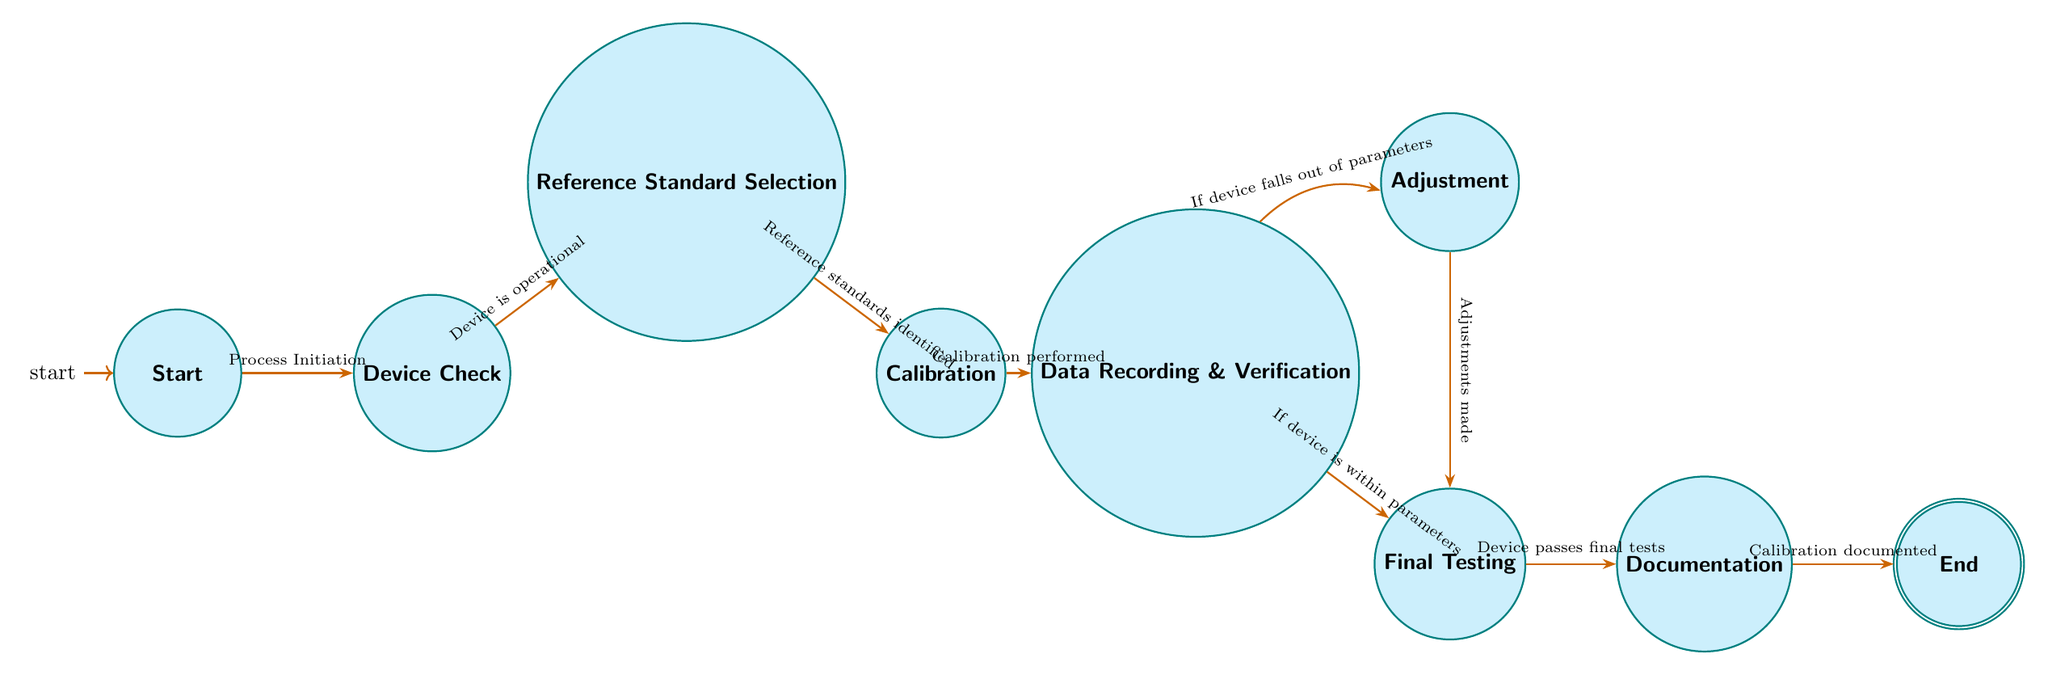What is the initial state in the calibration process? The diagram indicates that the initial state is labeled "Start." This is where the calibration process begins before any actions are taken.
Answer: Start How many nodes are present in the diagram? The diagram consists of nine nodes representing different states within the calibration process. Each node corresponds to a step, from the Start to the End.
Answer: Nine What condition transitions the process from "Device Check" to "Reference Standard Selection"? The transition condition from "Device Check" to "Reference Standard Selection" is specified as "Device is operational." This means that if the device is operational, the next step can be taken.
Answer: Device is operational If the device does not fall within specified parameters, which state does it lead to? If the device does not fall within specified parameters, the process transitions from "Data Recording & Verification" to "Adjustment." This allows for correcting errors in calibration.
Answer: Adjustment What is the final outcome once the calibration process is documented? The final outcome of the calibration process is indicated as "End." This state is reached after all previous states have been completed and the documentation is finished.
Answer: End What are the two possible transitions from "Data Recording & Verification"? The two possible transitions from "Data Recording & Verification" are "Adjustment" (if the device falls out of parameters) and "Final Testing" (if the device is within parameters). Both transitions depend on the evaluation of the calibration results.
Answer: Adjustment, Final Testing How many transitions occur before reaching the "Documentation" state? There are four transitions that need to happen to reach the "Documentation" state: from "Start" to "Device Check," then to "Reference Standard Selection," followed by "Calibration," and finally to "Data Recording & Verification."
Answer: Four What action leads from "Final Testing" to "Documentation"? The transition from "Final Testing" to "Documentation" is based upon the condition that states "Device passes final tests." If this condition is met, the process can advance to documentation.
Answer: Device passes final tests Which state is reached after adjustments are made? After adjustments are made, the process transitions to the "Final Testing" state, where the device's performance is tested to confirm it meets acceptable limits.
Answer: Final Testing 